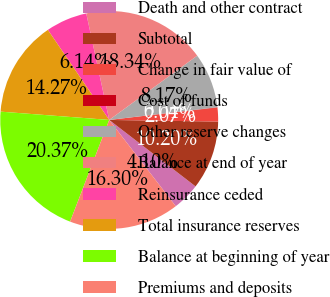Convert chart. <chart><loc_0><loc_0><loc_500><loc_500><pie_chart><fcel>Death and other contract<fcel>Subtotal<fcel>Change in fair value of<fcel>Cost of funds<fcel>Other reserve changes<fcel>Balance at end of year<fcel>Reinsurance ceded<fcel>Total insurance reserves<fcel>Balance at beginning of year<fcel>Premiums and deposits<nl><fcel>4.1%<fcel>10.2%<fcel>2.07%<fcel>0.04%<fcel>8.17%<fcel>18.34%<fcel>6.14%<fcel>14.27%<fcel>20.37%<fcel>16.3%<nl></chart> 